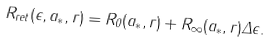<formula> <loc_0><loc_0><loc_500><loc_500>R _ { r e t } ( \epsilon , a _ { * } , r ) = R _ { 0 } ( a _ { * } , r ) + R _ { \infty } ( a _ { * } , r ) \Delta \epsilon .</formula> 